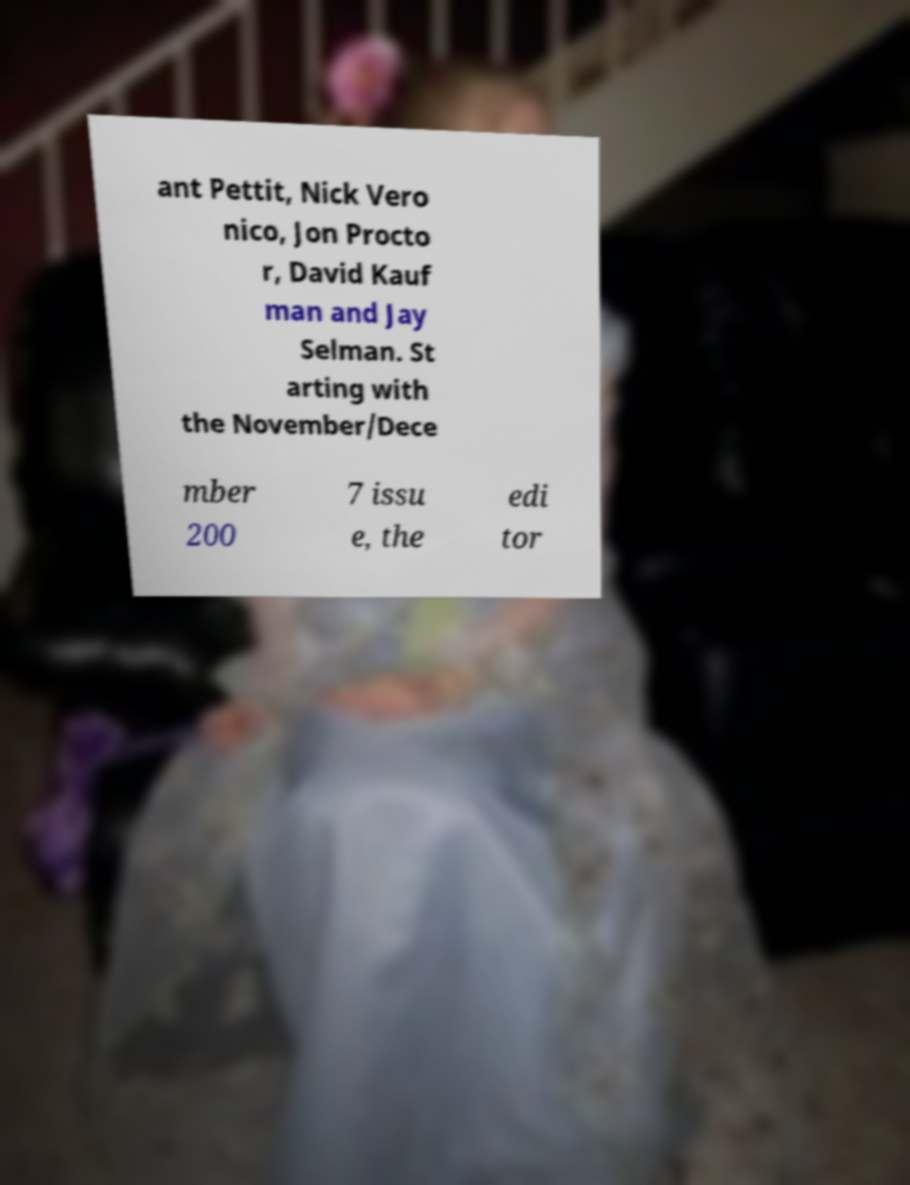I need the written content from this picture converted into text. Can you do that? ant Pettit, Nick Vero nico, Jon Procto r, David Kauf man and Jay Selman. St arting with the November/Dece mber 200 7 issu e, the edi tor 